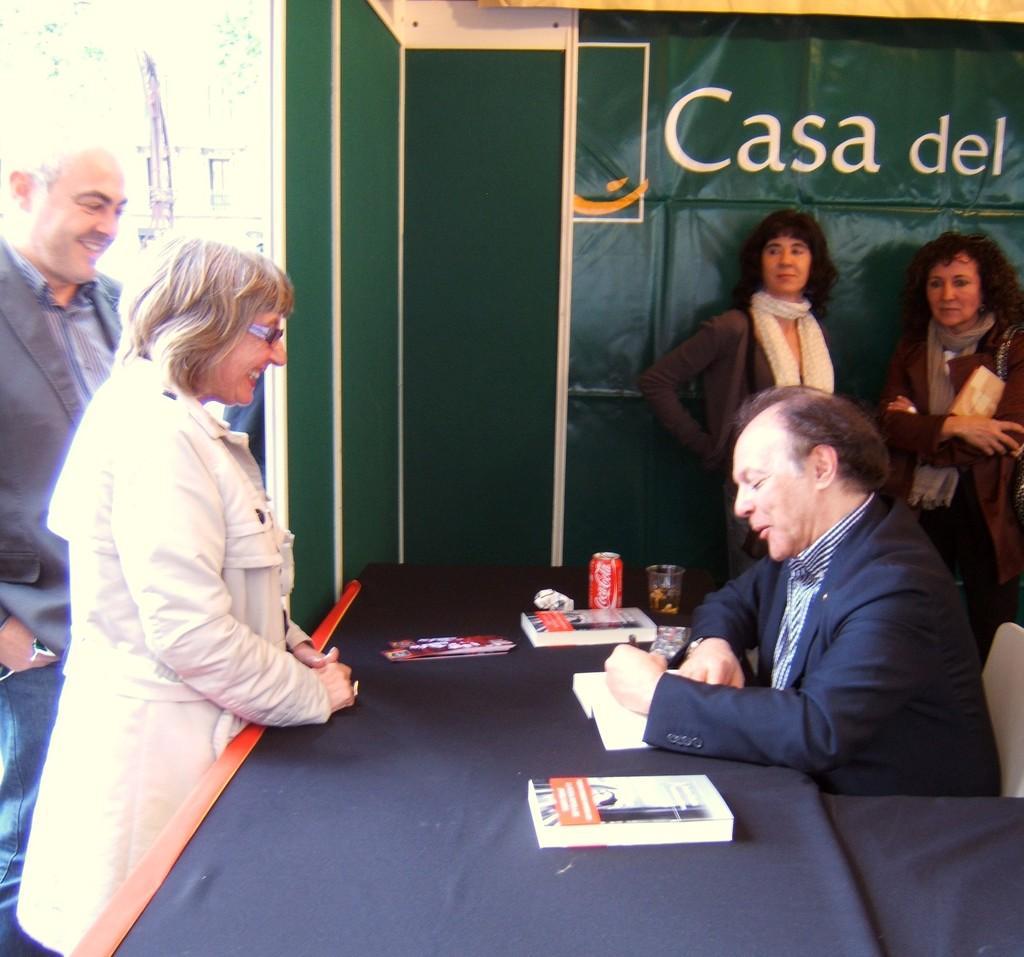Could you give a brief overview of what you see in this image? Here we can see a man sitting on a chair in front of a table and writing something on book. On the table we can see books, tin , glass. Near to it there is one woman standing and holding a smile on her face. Here we can see two women standing. Aside to this woman there is one man standing and smiling. On the background we can see a green colour cover sheet. This is a building. 